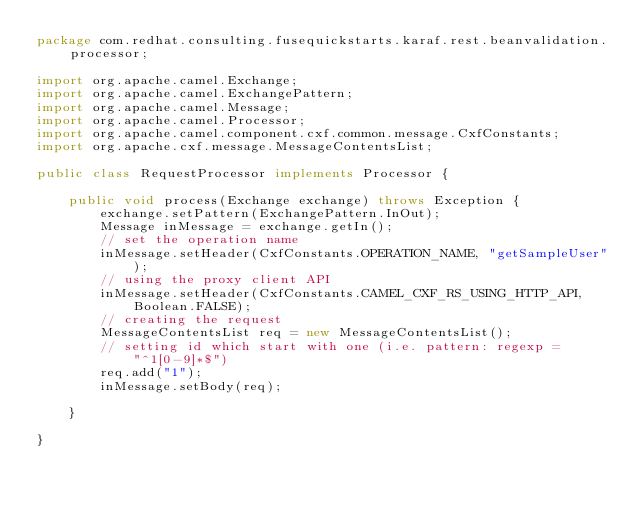Convert code to text. <code><loc_0><loc_0><loc_500><loc_500><_Java_>package com.redhat.consulting.fusequickstarts.karaf.rest.beanvalidation.processor;

import org.apache.camel.Exchange;
import org.apache.camel.ExchangePattern;
import org.apache.camel.Message;
import org.apache.camel.Processor;
import org.apache.camel.component.cxf.common.message.CxfConstants;
import org.apache.cxf.message.MessageContentsList;

public class RequestProcessor implements Processor {

    public void process(Exchange exchange) throws Exception {
        exchange.setPattern(ExchangePattern.InOut);
        Message inMessage = exchange.getIn();
        // set the operation name
        inMessage.setHeader(CxfConstants.OPERATION_NAME, "getSampleUser");
        // using the proxy client API
        inMessage.setHeader(CxfConstants.CAMEL_CXF_RS_USING_HTTP_API, Boolean.FALSE);
        // creating the request
        MessageContentsList req = new MessageContentsList();
        // setting id which start with one (i.e. pattern: regexp = "^1[0-9]*$")
        req.add("1");
        inMessage.setBody(req);

    }

}
</code> 